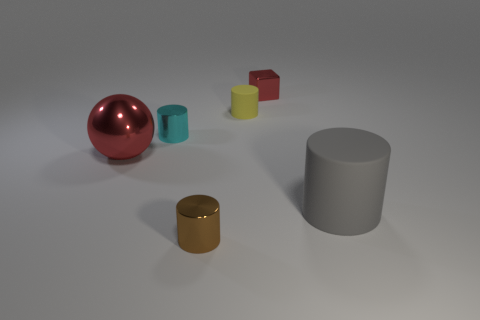Add 3 tiny cyan metal objects. How many objects exist? 9 Subtract all cubes. How many objects are left? 5 Subtract all blue spheres. Subtract all metallic cylinders. How many objects are left? 4 Add 1 red blocks. How many red blocks are left? 2 Add 1 red spheres. How many red spheres exist? 2 Subtract 1 red spheres. How many objects are left? 5 